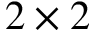<formula> <loc_0><loc_0><loc_500><loc_500>2 \times 2</formula> 